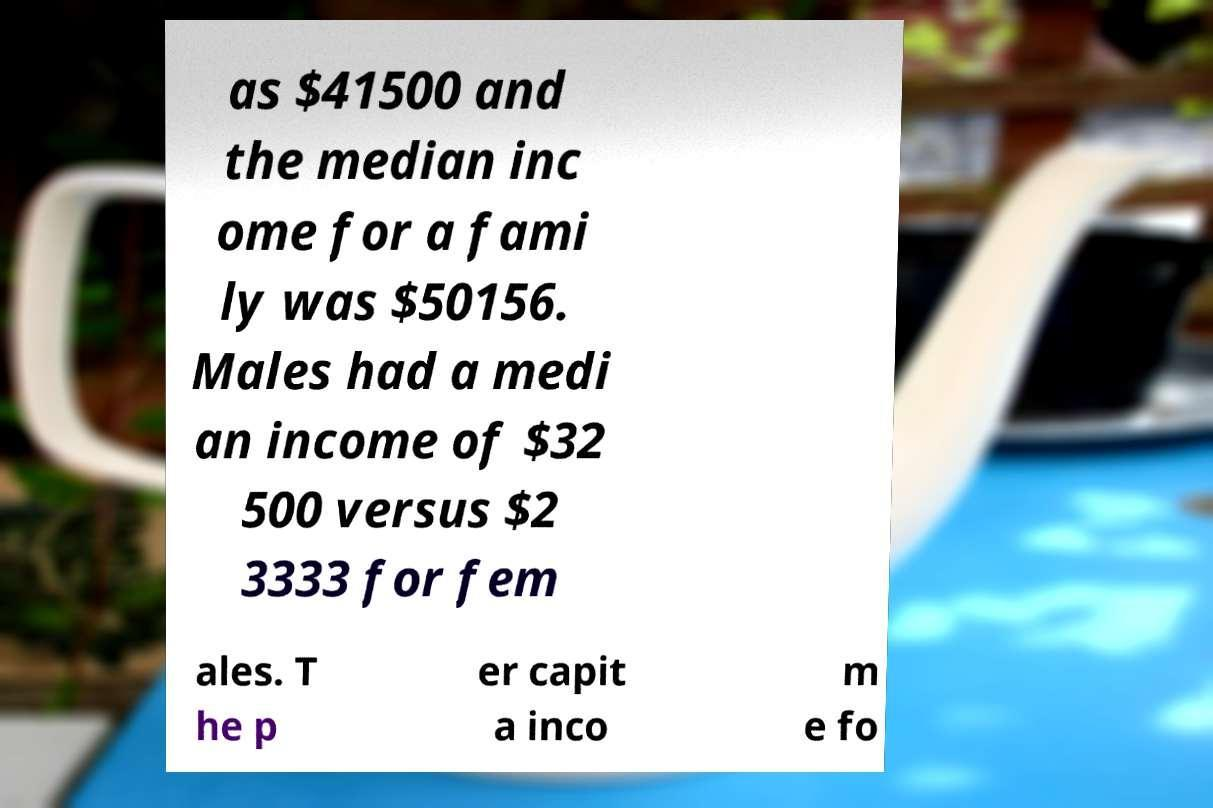For documentation purposes, I need the text within this image transcribed. Could you provide that? as $41500 and the median inc ome for a fami ly was $50156. Males had a medi an income of $32 500 versus $2 3333 for fem ales. T he p er capit a inco m e fo 